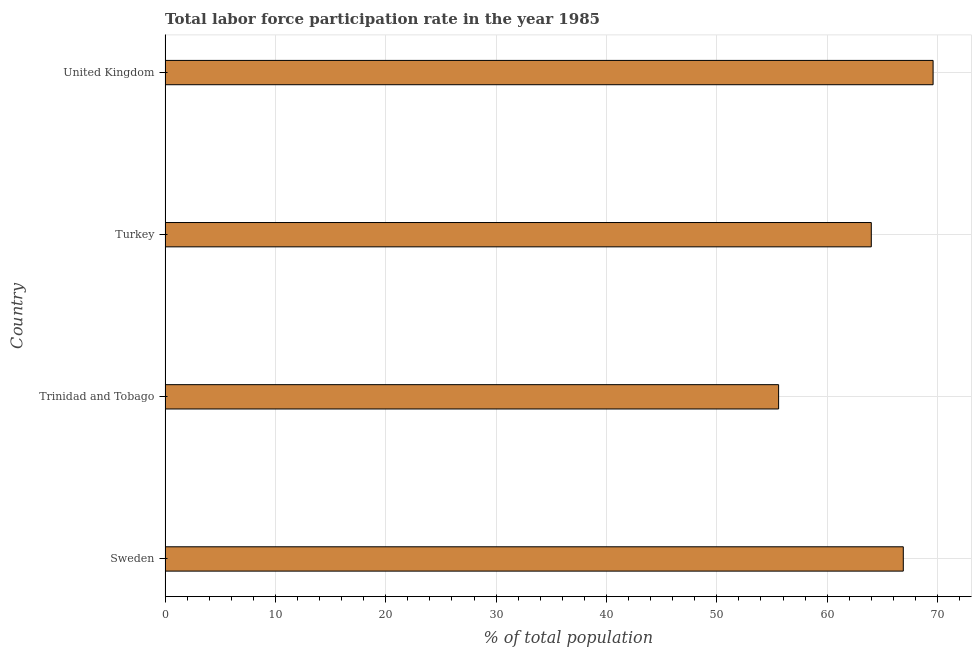Does the graph contain grids?
Your response must be concise. Yes. What is the title of the graph?
Provide a succinct answer. Total labor force participation rate in the year 1985. What is the label or title of the X-axis?
Provide a succinct answer. % of total population. What is the total labor force participation rate in Sweden?
Provide a succinct answer. 66.9. Across all countries, what is the maximum total labor force participation rate?
Offer a terse response. 69.6. Across all countries, what is the minimum total labor force participation rate?
Keep it short and to the point. 55.6. In which country was the total labor force participation rate maximum?
Your response must be concise. United Kingdom. In which country was the total labor force participation rate minimum?
Provide a short and direct response. Trinidad and Tobago. What is the sum of the total labor force participation rate?
Provide a succinct answer. 256.1. What is the difference between the total labor force participation rate in Sweden and Trinidad and Tobago?
Your answer should be compact. 11.3. What is the average total labor force participation rate per country?
Give a very brief answer. 64.03. What is the median total labor force participation rate?
Provide a short and direct response. 65.45. In how many countries, is the total labor force participation rate greater than 20 %?
Give a very brief answer. 4. What is the ratio of the total labor force participation rate in Sweden to that in Trinidad and Tobago?
Keep it short and to the point. 1.2. What is the difference between the highest and the second highest total labor force participation rate?
Offer a very short reply. 2.7. Is the sum of the total labor force participation rate in Sweden and Turkey greater than the maximum total labor force participation rate across all countries?
Your answer should be very brief. Yes. What is the difference between the highest and the lowest total labor force participation rate?
Your answer should be very brief. 14. In how many countries, is the total labor force participation rate greater than the average total labor force participation rate taken over all countries?
Make the answer very short. 2. How many bars are there?
Keep it short and to the point. 4. Are all the bars in the graph horizontal?
Your answer should be very brief. Yes. What is the % of total population in Sweden?
Offer a very short reply. 66.9. What is the % of total population in Trinidad and Tobago?
Provide a short and direct response. 55.6. What is the % of total population in Turkey?
Make the answer very short. 64. What is the % of total population of United Kingdom?
Ensure brevity in your answer.  69.6. What is the difference between the % of total population in Trinidad and Tobago and United Kingdom?
Offer a very short reply. -14. What is the difference between the % of total population in Turkey and United Kingdom?
Offer a terse response. -5.6. What is the ratio of the % of total population in Sweden to that in Trinidad and Tobago?
Keep it short and to the point. 1.2. What is the ratio of the % of total population in Sweden to that in Turkey?
Your answer should be very brief. 1.04. What is the ratio of the % of total population in Sweden to that in United Kingdom?
Offer a terse response. 0.96. What is the ratio of the % of total population in Trinidad and Tobago to that in Turkey?
Keep it short and to the point. 0.87. What is the ratio of the % of total population in Trinidad and Tobago to that in United Kingdom?
Your answer should be very brief. 0.8. 